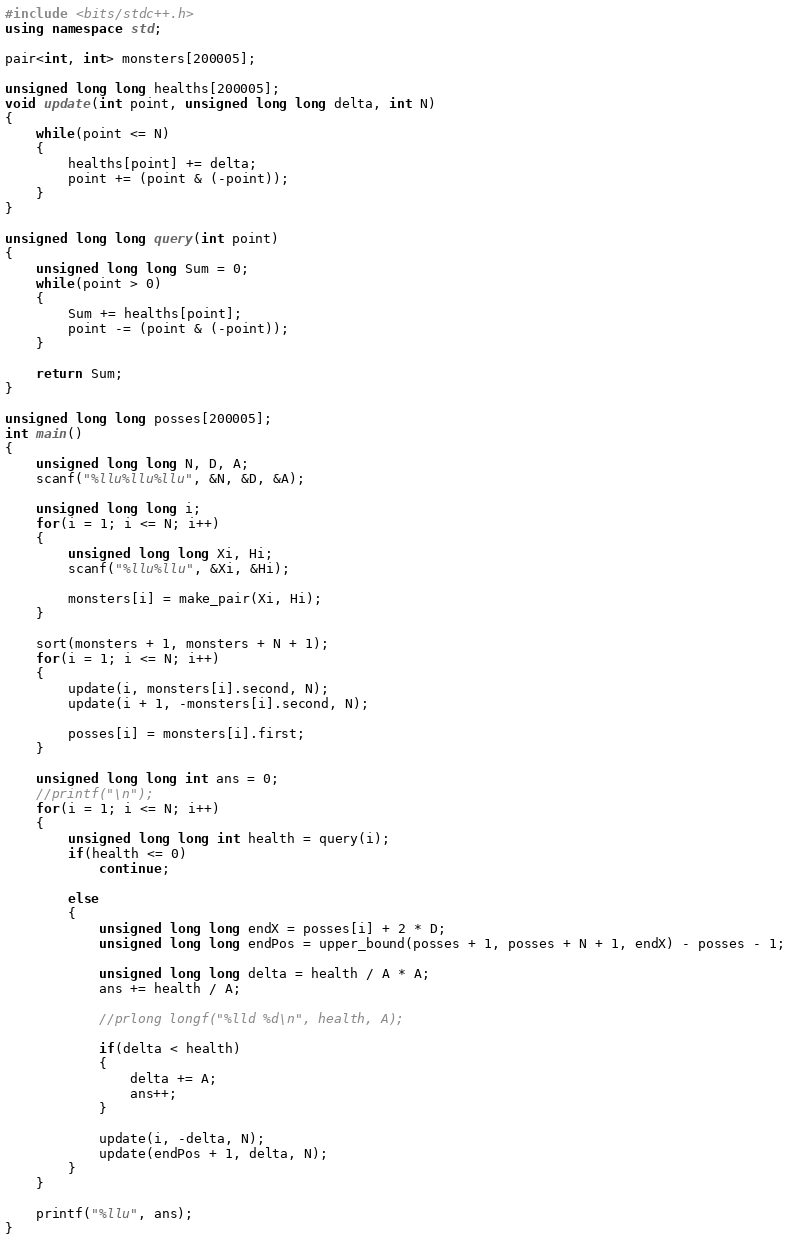<code> <loc_0><loc_0><loc_500><loc_500><_C++_>#include <bits/stdc++.h>
using namespace std;

pair<int, int> monsters[200005];

unsigned long long healths[200005];
void update(int point, unsigned long long delta, int N)
{
	while(point <= N)
	{
		healths[point] += delta;
		point += (point & (-point));
	}
}

unsigned long long query(int point)
{
	unsigned long long Sum = 0;
	while(point > 0)
	{
		Sum += healths[point];
		point -= (point & (-point));
	}
	
	return Sum;
}

unsigned long long posses[200005];
int main()
{
	unsigned long long N, D, A;
	scanf("%llu%llu%llu", &N, &D, &A);
	
	unsigned long long i;
	for(i = 1; i <= N; i++)
	{
		unsigned long long Xi, Hi;
		scanf("%llu%llu", &Xi, &Hi);
		
		monsters[i] = make_pair(Xi, Hi);
	}  
	
	sort(monsters + 1, monsters + N + 1);
	for(i = 1; i <= N; i++)
	{
		update(i, monsters[i].second, N);
		update(i + 1, -monsters[i].second, N);
		
		posses[i] = monsters[i].first;
	}
	
	unsigned long long int ans = 0;
	//printf("\n");
	for(i = 1; i <= N; i++)
	{
		unsigned long long int health = query(i);
		if(health <= 0)
			continue;
			
		else
		{
			unsigned long long endX = posses[i] + 2 * D;
			unsigned long long endPos = upper_bound(posses + 1, posses + N + 1, endX) - posses - 1;
			
			unsigned long long delta = health / A * A;
			ans += health / A;
			
			//prlong longf("%lld %d\n", health, A);
			
			if(delta < health)
			{
				delta += A;
				ans++;
			}
			
			update(i, -delta, N);
			update(endPos + 1, delta, N);
		}
	}	
	
	printf("%llu", ans);
}
</code> 